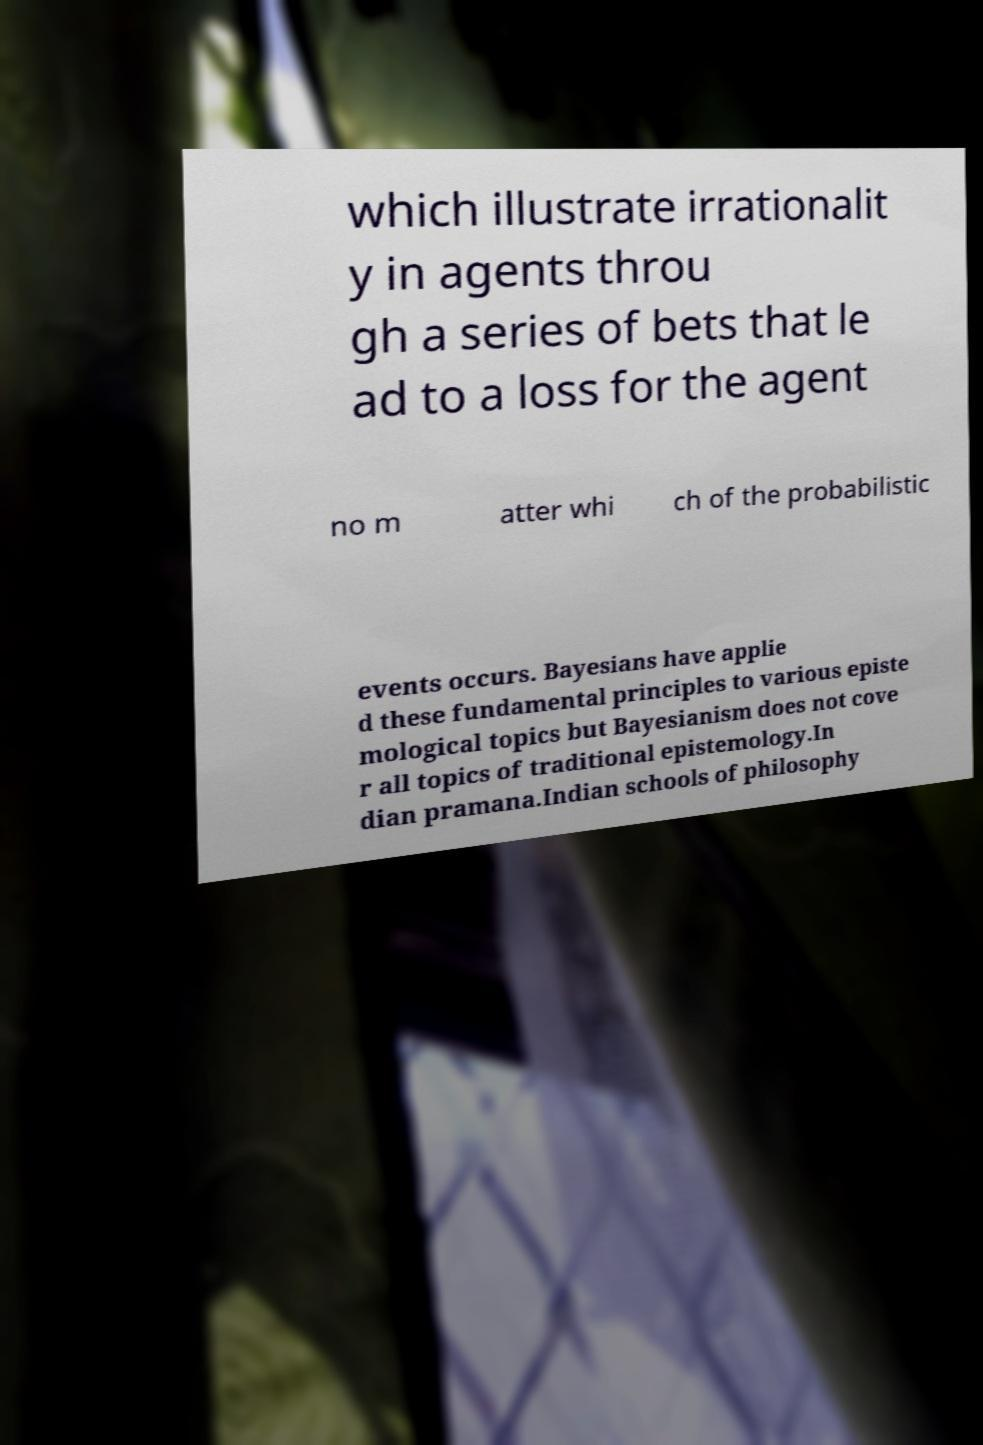Can you accurately transcribe the text from the provided image for me? which illustrate irrationalit y in agents throu gh a series of bets that le ad to a loss for the agent no m atter whi ch of the probabilistic events occurs. Bayesians have applie d these fundamental principles to various episte mological topics but Bayesianism does not cove r all topics of traditional epistemology.In dian pramana.Indian schools of philosophy 